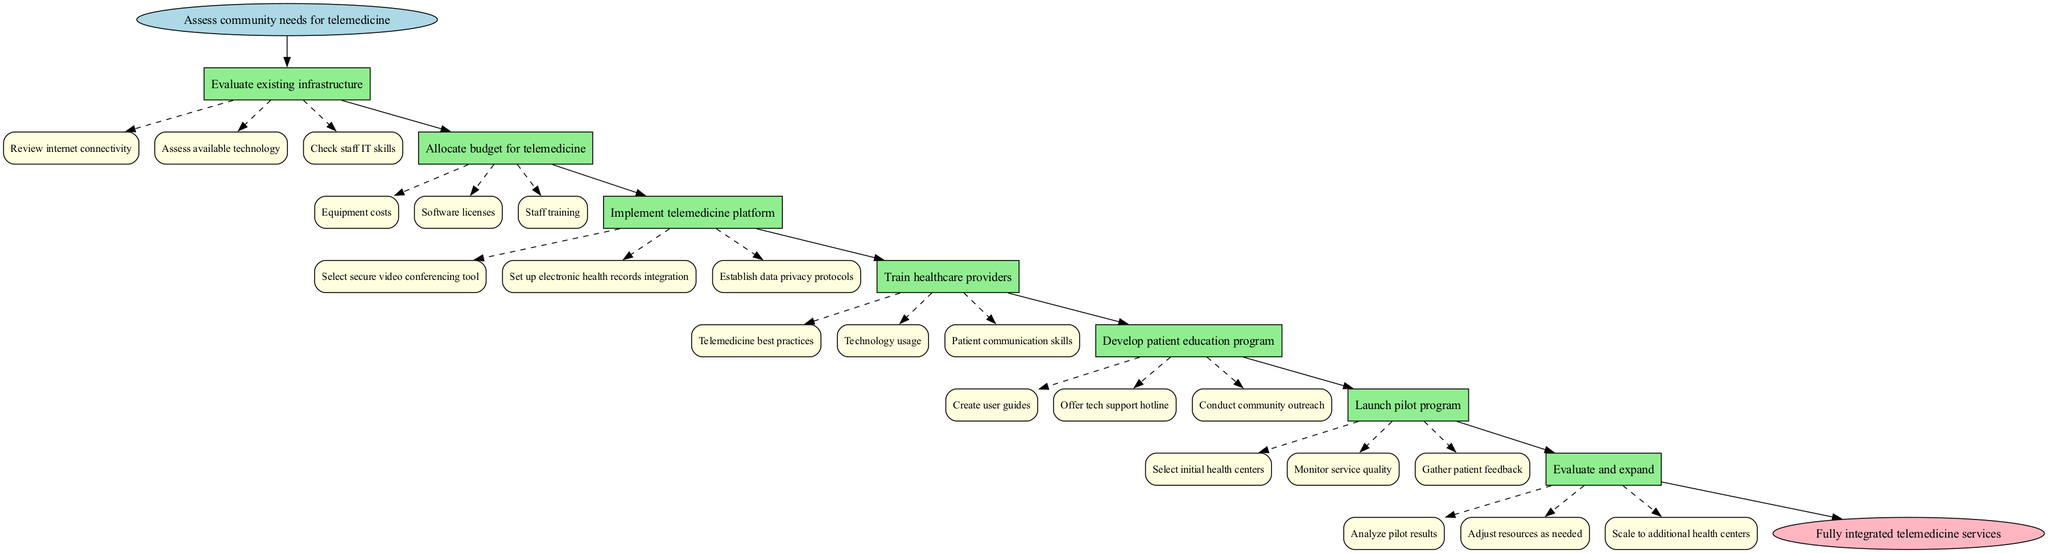What is the first step in implementing telemedicine services? The first step is labeled as "Assess community needs for telemedicine." This is clearly indicated as the starting point in the diagram.
Answer: Assess community needs for telemedicine How many main steps are involved in the telemedicine implementation pathway? There are seven main steps visible in the sequence from the start node to the end node which contribute to the overall pathway.
Answer: 7 What is the last step before the end node? The last step before reaching the end node is "Evaluate and expand," which is the final action to be taken in the sequence.
Answer: Evaluate and expand Which substep involves assessing technology used in the center? The substep "Assess available technology" falls under the main step "Evaluate existing infrastructure," which is relevant to understanding the technological setup at the community health centers.
Answer: Assess available technology What is a requirement for the implementation of the telemedicine platform? One of the requirements is to "Select secure video conferencing tool," which is part of the implementation process of the telemedicine platform.
Answer: Select secure video conferencing tool What actions are included in the pilot program launch? The pilot program launch involves "Select initial health centers," "Monitor service quality," and "Gather patient feedback." These actions are critical for testing the telemedicine services before a full rollout.
Answer: Select initial health centers, Monitor service quality, Gather patient feedback How is patient education structured in this pathway? The development of a patient education program includes creating user guides, offering a tech support hotline, and conducting community outreach. This structure is essential to ensure patients are informed and comfortable using telemedicine services.
Answer: Create user guides, Offer tech support hotline, Conduct community outreach What is the relationship between the steps “Allocate budget for telemedicine” and "Train healthcare providers"? The step "Allocate budget for telemedicine" identifies funding essentials, and after that, "Train healthcare providers" focuses on preparing medical staff, indicating a sequential dependency where adequate funding enables effective training. This shows a direct flow from budget allocation to provider training.
Answer: Sequential dependency What occurs after evaluating the pilot program? After evaluating the pilot program, the next step is to "Analyze pilot results," followed by adjusting resources and scaling to additional health centers, showing the pathway towards expansion based on the pilot evaluation.
Answer: Analyze pilot results 